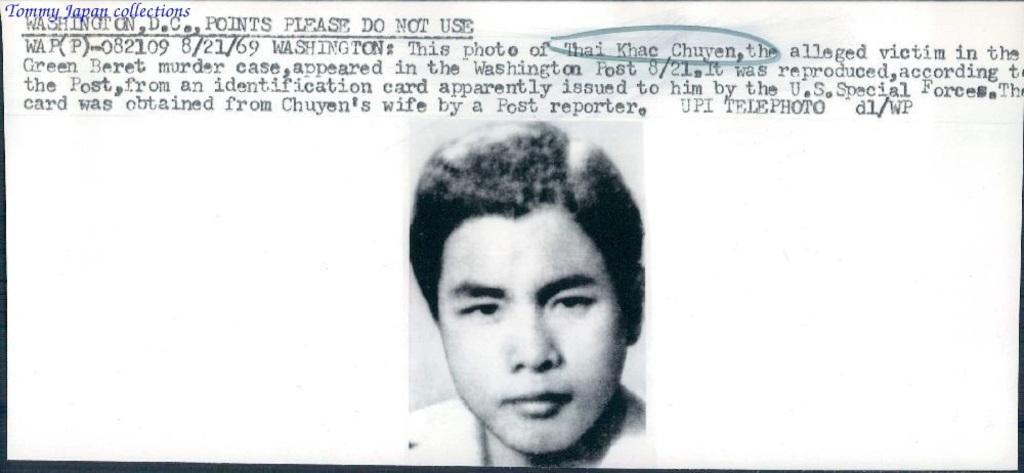How would you summarize this image in a sentence or two? In this image I can see the black and white picture of a person and on the top of the image I can see few words written with black color. I can see the white colored background. 